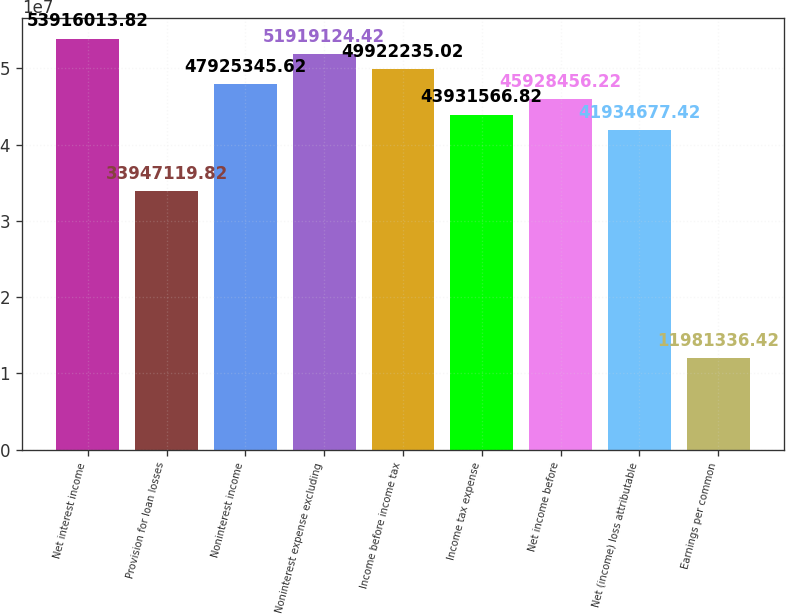<chart> <loc_0><loc_0><loc_500><loc_500><bar_chart><fcel>Net interest income<fcel>Provision for loan losses<fcel>Noninterest income<fcel>Noninterest expense excluding<fcel>Income before income tax<fcel>Income tax expense<fcel>Net income before<fcel>Net (income) loss attributable<fcel>Earnings per common<nl><fcel>5.3916e+07<fcel>3.39471e+07<fcel>4.79253e+07<fcel>5.19191e+07<fcel>4.99222e+07<fcel>4.39316e+07<fcel>4.59285e+07<fcel>4.19347e+07<fcel>1.19813e+07<nl></chart> 